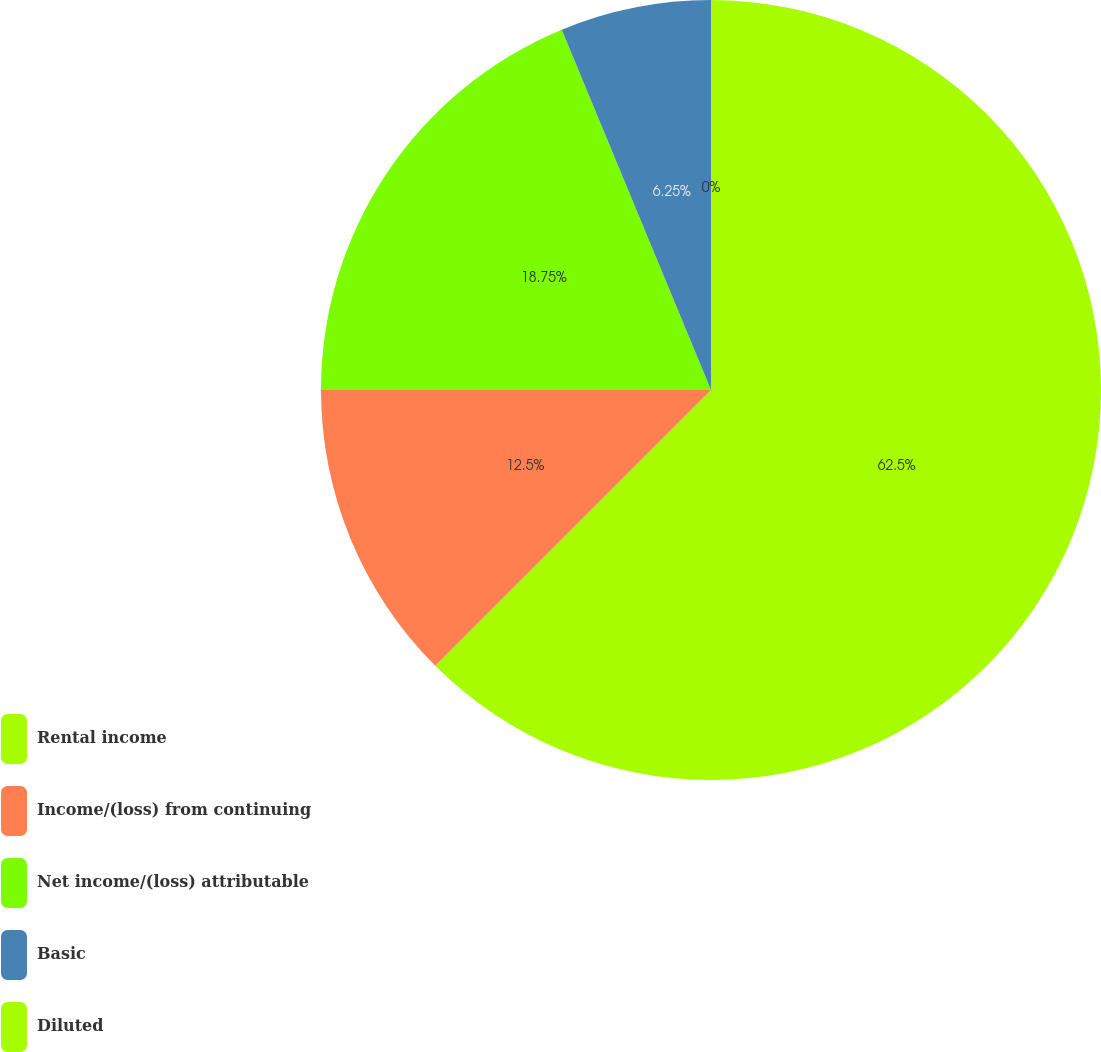<chart> <loc_0><loc_0><loc_500><loc_500><pie_chart><fcel>Rental income<fcel>Income/(loss) from continuing<fcel>Net income/(loss) attributable<fcel>Basic<fcel>Diluted<nl><fcel>62.5%<fcel>12.5%<fcel>18.75%<fcel>6.25%<fcel>0.0%<nl></chart> 